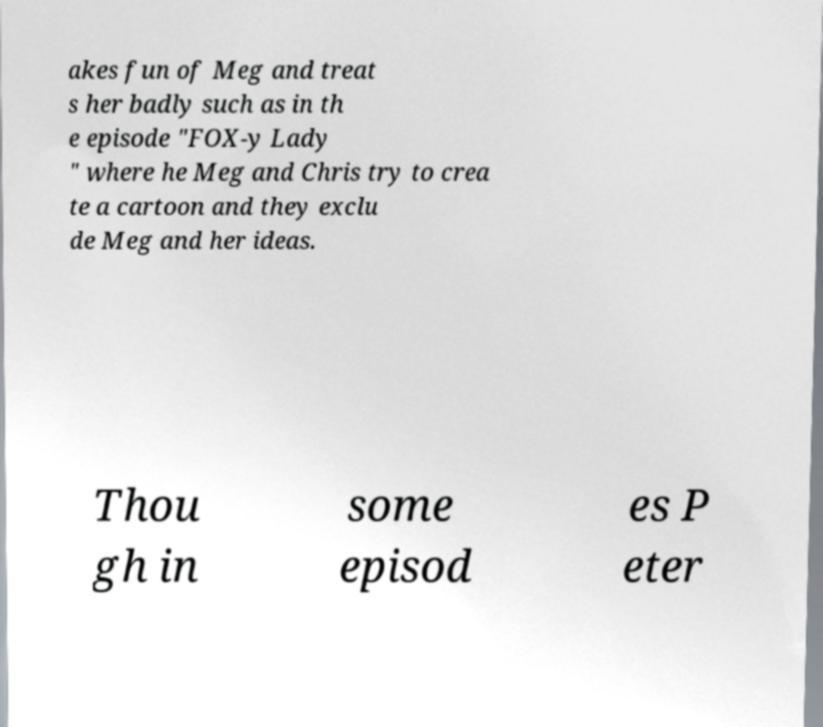Could you assist in decoding the text presented in this image and type it out clearly? akes fun of Meg and treat s her badly such as in th e episode "FOX-y Lady " where he Meg and Chris try to crea te a cartoon and they exclu de Meg and her ideas. Thou gh in some episod es P eter 